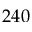<formula> <loc_0><loc_0><loc_500><loc_500>2 4 0</formula> 